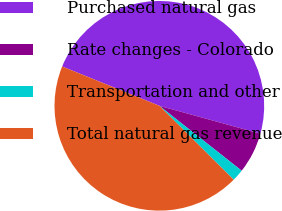<chart> <loc_0><loc_0><loc_500><loc_500><pie_chart><fcel>Purchased natural gas<fcel>Rate changes - Colorado<fcel>Transportation and other<fcel>Total natural gas revenue<nl><fcel>48.17%<fcel>6.34%<fcel>1.83%<fcel>43.66%<nl></chart> 